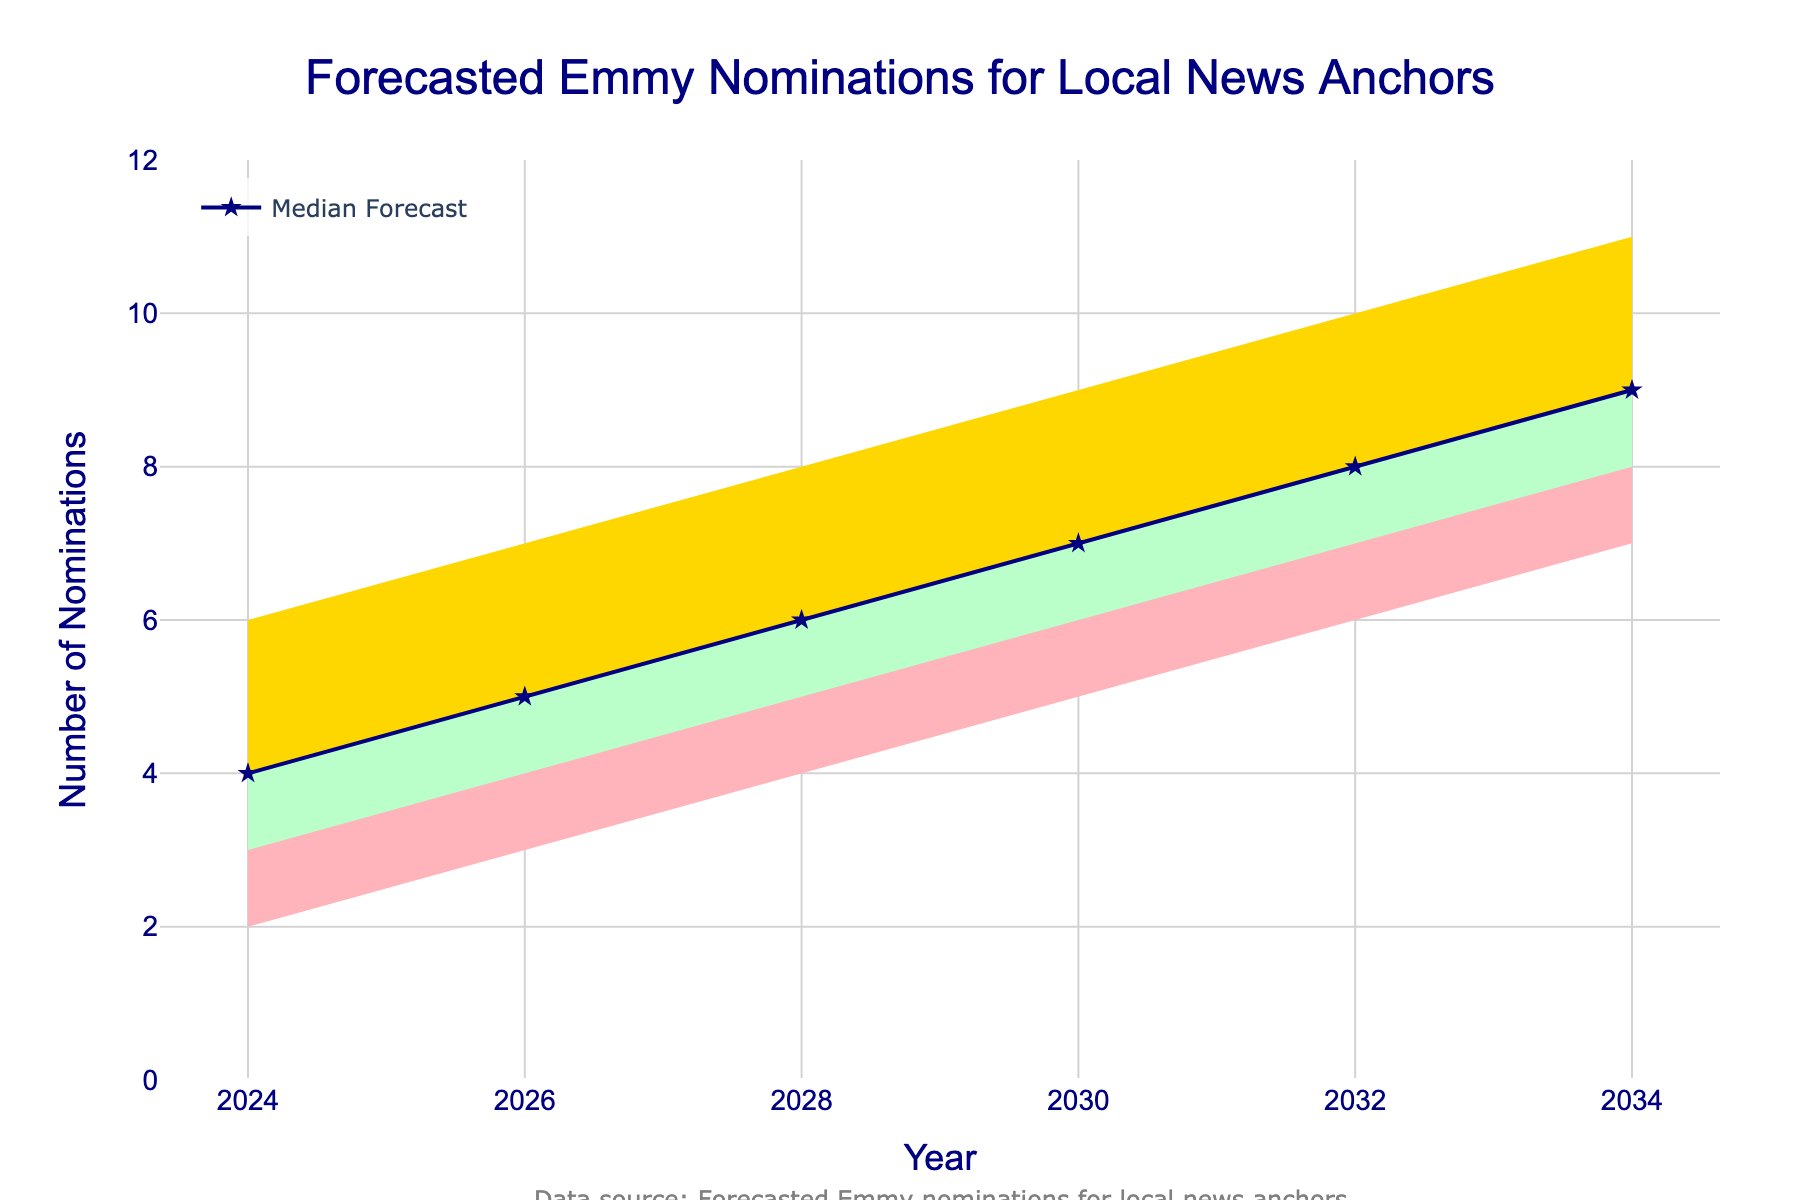What's the title of the figure? The title is usually placed at the top of the figure. In this case, it reads "Forecasted Emmy Nominations for Local News Anchors."
Answer: Forecasted Emmy Nominations for Local News Anchors What is the forecasted median number of Emmy nominations in 2030? The median number is represented by the navy line marked with stars. For 2030, the point on this line is at 7 nominations.
Answer: 7 What year is expected to have the highest median number of Emmy nominations? By identifying the highest point on the navy line, we see that the year 2034 has the highest median number of 9 nominations.
Answer: 2034 Between which two years is the increase in the median number of nominations the largest? By looking at the increments on the navy line, compare year-to-year changes. The largest increase occurs between 2026 (5 nominations) to 2028 (6 nominations), an increase of 1.
Answer: 2026 to 2028 How many different forecast ranges are depicted in the figure? The forecast ranges correspond to the shaded areas in different colors. There are five ranges indicated by five different colors.
Answer: 5 In 2028, how much higher could the highest possible number of nominations be compared to the lowest possible number? In 2028, the highest number of nominations is 8 and the lowest is 4. So, the difference is 8 - 4 = 4.
Answer: 4 What is the color of the area representing the highest forecast range? The color of the area at the topmost range is specified by a golden-yellow color.
Answer: Golden-yellow Which year has the narrowest forecast range between the low and high ends? By comparing the width of the shaded areas for each year, the smallest range (lowest difference) appears in 2024: 6 (high) - 2 (low) equals 4.
Answer: 2024 Approximately how many Emmy nominations could be predicted as the middle point of the range in 2032? The middle point within the year 2032 forecast is represented by the middle color range. In this case, it is 8 nominations.
Answer: 8 Between 2024 and 2034, how many years have their forecasted median nominations increasing steadily? The median nominations (navy line) rise steadily each year from 2024 through 2034, making it a total span of 6 years.
Answer: 6 